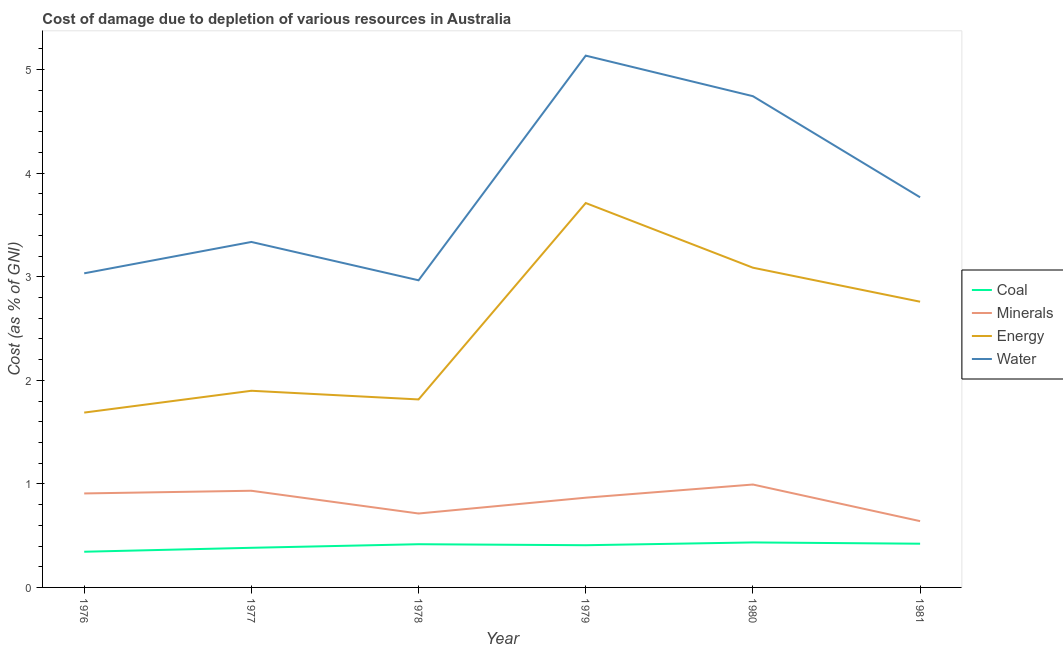Is the number of lines equal to the number of legend labels?
Make the answer very short. Yes. What is the cost of damage due to depletion of energy in 1981?
Offer a very short reply. 2.76. Across all years, what is the maximum cost of damage due to depletion of energy?
Your answer should be compact. 3.71. Across all years, what is the minimum cost of damage due to depletion of water?
Your answer should be compact. 2.97. In which year was the cost of damage due to depletion of minerals maximum?
Ensure brevity in your answer.  1980. In which year was the cost of damage due to depletion of water minimum?
Give a very brief answer. 1978. What is the total cost of damage due to depletion of coal in the graph?
Offer a terse response. 2.41. What is the difference between the cost of damage due to depletion of energy in 1977 and that in 1979?
Offer a very short reply. -1.81. What is the difference between the cost of damage due to depletion of minerals in 1978 and the cost of damage due to depletion of energy in 1979?
Offer a very short reply. -3. What is the average cost of damage due to depletion of minerals per year?
Give a very brief answer. 0.84. In the year 1981, what is the difference between the cost of damage due to depletion of minerals and cost of damage due to depletion of energy?
Offer a very short reply. -2.12. In how many years, is the cost of damage due to depletion of water greater than 4.4 %?
Offer a very short reply. 2. What is the ratio of the cost of damage due to depletion of minerals in 1977 to that in 1980?
Ensure brevity in your answer.  0.94. Is the difference between the cost of damage due to depletion of minerals in 1980 and 1981 greater than the difference between the cost of damage due to depletion of water in 1980 and 1981?
Your answer should be very brief. No. What is the difference between the highest and the second highest cost of damage due to depletion of water?
Offer a terse response. 0.39. What is the difference between the highest and the lowest cost of damage due to depletion of energy?
Offer a terse response. 2.02. Does the cost of damage due to depletion of coal monotonically increase over the years?
Your response must be concise. No. Is the cost of damage due to depletion of water strictly greater than the cost of damage due to depletion of minerals over the years?
Offer a very short reply. Yes. Is the cost of damage due to depletion of minerals strictly less than the cost of damage due to depletion of energy over the years?
Your answer should be very brief. Yes. How many lines are there?
Keep it short and to the point. 4. How many years are there in the graph?
Keep it short and to the point. 6. What is the difference between two consecutive major ticks on the Y-axis?
Keep it short and to the point. 1. Are the values on the major ticks of Y-axis written in scientific E-notation?
Offer a terse response. No. Does the graph contain grids?
Your answer should be very brief. No. How many legend labels are there?
Offer a terse response. 4. What is the title of the graph?
Keep it short and to the point. Cost of damage due to depletion of various resources in Australia . What is the label or title of the Y-axis?
Offer a very short reply. Cost (as % of GNI). What is the Cost (as % of GNI) of Coal in 1976?
Offer a very short reply. 0.34. What is the Cost (as % of GNI) in Minerals in 1976?
Make the answer very short. 0.91. What is the Cost (as % of GNI) in Energy in 1976?
Offer a terse response. 1.69. What is the Cost (as % of GNI) in Water in 1976?
Your answer should be very brief. 3.03. What is the Cost (as % of GNI) in Coal in 1977?
Your answer should be very brief. 0.38. What is the Cost (as % of GNI) in Minerals in 1977?
Provide a succinct answer. 0.93. What is the Cost (as % of GNI) of Energy in 1977?
Your answer should be very brief. 1.9. What is the Cost (as % of GNI) in Water in 1977?
Offer a very short reply. 3.34. What is the Cost (as % of GNI) in Coal in 1978?
Keep it short and to the point. 0.42. What is the Cost (as % of GNI) of Minerals in 1978?
Offer a very short reply. 0.71. What is the Cost (as % of GNI) in Energy in 1978?
Keep it short and to the point. 1.82. What is the Cost (as % of GNI) in Water in 1978?
Your response must be concise. 2.97. What is the Cost (as % of GNI) of Coal in 1979?
Your answer should be compact. 0.41. What is the Cost (as % of GNI) in Minerals in 1979?
Offer a terse response. 0.87. What is the Cost (as % of GNI) in Energy in 1979?
Your answer should be very brief. 3.71. What is the Cost (as % of GNI) of Water in 1979?
Your answer should be compact. 5.14. What is the Cost (as % of GNI) in Coal in 1980?
Provide a short and direct response. 0.43. What is the Cost (as % of GNI) in Minerals in 1980?
Provide a short and direct response. 0.99. What is the Cost (as % of GNI) in Energy in 1980?
Your answer should be very brief. 3.09. What is the Cost (as % of GNI) of Water in 1980?
Give a very brief answer. 4.74. What is the Cost (as % of GNI) in Coal in 1981?
Ensure brevity in your answer.  0.42. What is the Cost (as % of GNI) in Minerals in 1981?
Give a very brief answer. 0.64. What is the Cost (as % of GNI) in Energy in 1981?
Your response must be concise. 2.76. What is the Cost (as % of GNI) of Water in 1981?
Provide a short and direct response. 3.77. Across all years, what is the maximum Cost (as % of GNI) in Coal?
Ensure brevity in your answer.  0.43. Across all years, what is the maximum Cost (as % of GNI) in Minerals?
Your answer should be compact. 0.99. Across all years, what is the maximum Cost (as % of GNI) of Energy?
Provide a succinct answer. 3.71. Across all years, what is the maximum Cost (as % of GNI) of Water?
Provide a succinct answer. 5.14. Across all years, what is the minimum Cost (as % of GNI) in Coal?
Your response must be concise. 0.34. Across all years, what is the minimum Cost (as % of GNI) in Minerals?
Provide a succinct answer. 0.64. Across all years, what is the minimum Cost (as % of GNI) of Energy?
Offer a very short reply. 1.69. Across all years, what is the minimum Cost (as % of GNI) in Water?
Offer a very short reply. 2.97. What is the total Cost (as % of GNI) in Coal in the graph?
Provide a succinct answer. 2.41. What is the total Cost (as % of GNI) in Minerals in the graph?
Your response must be concise. 5.06. What is the total Cost (as % of GNI) of Energy in the graph?
Provide a succinct answer. 14.96. What is the total Cost (as % of GNI) in Water in the graph?
Offer a terse response. 22.98. What is the difference between the Cost (as % of GNI) in Coal in 1976 and that in 1977?
Ensure brevity in your answer.  -0.04. What is the difference between the Cost (as % of GNI) in Minerals in 1976 and that in 1977?
Offer a terse response. -0.03. What is the difference between the Cost (as % of GNI) in Energy in 1976 and that in 1977?
Provide a succinct answer. -0.21. What is the difference between the Cost (as % of GNI) of Water in 1976 and that in 1977?
Make the answer very short. -0.3. What is the difference between the Cost (as % of GNI) of Coal in 1976 and that in 1978?
Your answer should be compact. -0.07. What is the difference between the Cost (as % of GNI) of Minerals in 1976 and that in 1978?
Make the answer very short. 0.19. What is the difference between the Cost (as % of GNI) of Energy in 1976 and that in 1978?
Give a very brief answer. -0.13. What is the difference between the Cost (as % of GNI) of Water in 1976 and that in 1978?
Give a very brief answer. 0.07. What is the difference between the Cost (as % of GNI) of Coal in 1976 and that in 1979?
Ensure brevity in your answer.  -0.06. What is the difference between the Cost (as % of GNI) of Minerals in 1976 and that in 1979?
Give a very brief answer. 0.04. What is the difference between the Cost (as % of GNI) in Energy in 1976 and that in 1979?
Provide a short and direct response. -2.02. What is the difference between the Cost (as % of GNI) in Water in 1976 and that in 1979?
Offer a terse response. -2.1. What is the difference between the Cost (as % of GNI) of Coal in 1976 and that in 1980?
Provide a short and direct response. -0.09. What is the difference between the Cost (as % of GNI) in Minerals in 1976 and that in 1980?
Your response must be concise. -0.09. What is the difference between the Cost (as % of GNI) in Energy in 1976 and that in 1980?
Offer a very short reply. -1.4. What is the difference between the Cost (as % of GNI) in Water in 1976 and that in 1980?
Provide a succinct answer. -1.71. What is the difference between the Cost (as % of GNI) in Coal in 1976 and that in 1981?
Provide a succinct answer. -0.08. What is the difference between the Cost (as % of GNI) in Minerals in 1976 and that in 1981?
Make the answer very short. 0.27. What is the difference between the Cost (as % of GNI) of Energy in 1976 and that in 1981?
Offer a very short reply. -1.07. What is the difference between the Cost (as % of GNI) in Water in 1976 and that in 1981?
Offer a very short reply. -0.73. What is the difference between the Cost (as % of GNI) in Coal in 1977 and that in 1978?
Ensure brevity in your answer.  -0.03. What is the difference between the Cost (as % of GNI) in Minerals in 1977 and that in 1978?
Keep it short and to the point. 0.22. What is the difference between the Cost (as % of GNI) of Energy in 1977 and that in 1978?
Make the answer very short. 0.08. What is the difference between the Cost (as % of GNI) of Water in 1977 and that in 1978?
Give a very brief answer. 0.37. What is the difference between the Cost (as % of GNI) in Coal in 1977 and that in 1979?
Your answer should be compact. -0.02. What is the difference between the Cost (as % of GNI) of Minerals in 1977 and that in 1979?
Your answer should be compact. 0.07. What is the difference between the Cost (as % of GNI) of Energy in 1977 and that in 1979?
Provide a short and direct response. -1.81. What is the difference between the Cost (as % of GNI) of Water in 1977 and that in 1979?
Offer a very short reply. -1.8. What is the difference between the Cost (as % of GNI) in Coal in 1977 and that in 1980?
Your answer should be very brief. -0.05. What is the difference between the Cost (as % of GNI) in Minerals in 1977 and that in 1980?
Make the answer very short. -0.06. What is the difference between the Cost (as % of GNI) in Energy in 1977 and that in 1980?
Offer a terse response. -1.19. What is the difference between the Cost (as % of GNI) of Water in 1977 and that in 1980?
Your answer should be compact. -1.41. What is the difference between the Cost (as % of GNI) in Coal in 1977 and that in 1981?
Make the answer very short. -0.04. What is the difference between the Cost (as % of GNI) of Minerals in 1977 and that in 1981?
Provide a succinct answer. 0.29. What is the difference between the Cost (as % of GNI) of Energy in 1977 and that in 1981?
Offer a terse response. -0.86. What is the difference between the Cost (as % of GNI) of Water in 1977 and that in 1981?
Provide a succinct answer. -0.43. What is the difference between the Cost (as % of GNI) in Coal in 1978 and that in 1979?
Offer a terse response. 0.01. What is the difference between the Cost (as % of GNI) in Minerals in 1978 and that in 1979?
Offer a very short reply. -0.15. What is the difference between the Cost (as % of GNI) of Energy in 1978 and that in 1979?
Offer a very short reply. -1.9. What is the difference between the Cost (as % of GNI) in Water in 1978 and that in 1979?
Ensure brevity in your answer.  -2.17. What is the difference between the Cost (as % of GNI) in Coal in 1978 and that in 1980?
Ensure brevity in your answer.  -0.02. What is the difference between the Cost (as % of GNI) of Minerals in 1978 and that in 1980?
Make the answer very short. -0.28. What is the difference between the Cost (as % of GNI) of Energy in 1978 and that in 1980?
Make the answer very short. -1.27. What is the difference between the Cost (as % of GNI) of Water in 1978 and that in 1980?
Keep it short and to the point. -1.78. What is the difference between the Cost (as % of GNI) in Coal in 1978 and that in 1981?
Provide a short and direct response. -0. What is the difference between the Cost (as % of GNI) of Minerals in 1978 and that in 1981?
Provide a succinct answer. 0.07. What is the difference between the Cost (as % of GNI) in Energy in 1978 and that in 1981?
Provide a succinct answer. -0.94. What is the difference between the Cost (as % of GNI) in Water in 1978 and that in 1981?
Your response must be concise. -0.8. What is the difference between the Cost (as % of GNI) in Coal in 1979 and that in 1980?
Your answer should be very brief. -0.03. What is the difference between the Cost (as % of GNI) of Minerals in 1979 and that in 1980?
Give a very brief answer. -0.13. What is the difference between the Cost (as % of GNI) of Energy in 1979 and that in 1980?
Your answer should be very brief. 0.62. What is the difference between the Cost (as % of GNI) of Water in 1979 and that in 1980?
Provide a short and direct response. 0.39. What is the difference between the Cost (as % of GNI) in Coal in 1979 and that in 1981?
Make the answer very short. -0.01. What is the difference between the Cost (as % of GNI) of Minerals in 1979 and that in 1981?
Provide a succinct answer. 0.23. What is the difference between the Cost (as % of GNI) in Energy in 1979 and that in 1981?
Give a very brief answer. 0.95. What is the difference between the Cost (as % of GNI) of Water in 1979 and that in 1981?
Offer a terse response. 1.37. What is the difference between the Cost (as % of GNI) in Coal in 1980 and that in 1981?
Your answer should be very brief. 0.01. What is the difference between the Cost (as % of GNI) of Minerals in 1980 and that in 1981?
Your answer should be very brief. 0.35. What is the difference between the Cost (as % of GNI) in Energy in 1980 and that in 1981?
Provide a short and direct response. 0.33. What is the difference between the Cost (as % of GNI) in Water in 1980 and that in 1981?
Your answer should be very brief. 0.98. What is the difference between the Cost (as % of GNI) in Coal in 1976 and the Cost (as % of GNI) in Minerals in 1977?
Make the answer very short. -0.59. What is the difference between the Cost (as % of GNI) of Coal in 1976 and the Cost (as % of GNI) of Energy in 1977?
Keep it short and to the point. -1.55. What is the difference between the Cost (as % of GNI) of Coal in 1976 and the Cost (as % of GNI) of Water in 1977?
Your response must be concise. -2.99. What is the difference between the Cost (as % of GNI) of Minerals in 1976 and the Cost (as % of GNI) of Energy in 1977?
Offer a very short reply. -0.99. What is the difference between the Cost (as % of GNI) in Minerals in 1976 and the Cost (as % of GNI) in Water in 1977?
Keep it short and to the point. -2.43. What is the difference between the Cost (as % of GNI) of Energy in 1976 and the Cost (as % of GNI) of Water in 1977?
Ensure brevity in your answer.  -1.65. What is the difference between the Cost (as % of GNI) in Coal in 1976 and the Cost (as % of GNI) in Minerals in 1978?
Give a very brief answer. -0.37. What is the difference between the Cost (as % of GNI) of Coal in 1976 and the Cost (as % of GNI) of Energy in 1978?
Provide a short and direct response. -1.47. What is the difference between the Cost (as % of GNI) in Coal in 1976 and the Cost (as % of GNI) in Water in 1978?
Your answer should be very brief. -2.62. What is the difference between the Cost (as % of GNI) in Minerals in 1976 and the Cost (as % of GNI) in Energy in 1978?
Make the answer very short. -0.91. What is the difference between the Cost (as % of GNI) of Minerals in 1976 and the Cost (as % of GNI) of Water in 1978?
Ensure brevity in your answer.  -2.06. What is the difference between the Cost (as % of GNI) in Energy in 1976 and the Cost (as % of GNI) in Water in 1978?
Offer a terse response. -1.28. What is the difference between the Cost (as % of GNI) in Coal in 1976 and the Cost (as % of GNI) in Minerals in 1979?
Offer a terse response. -0.52. What is the difference between the Cost (as % of GNI) of Coal in 1976 and the Cost (as % of GNI) of Energy in 1979?
Ensure brevity in your answer.  -3.37. What is the difference between the Cost (as % of GNI) in Coal in 1976 and the Cost (as % of GNI) in Water in 1979?
Give a very brief answer. -4.79. What is the difference between the Cost (as % of GNI) of Minerals in 1976 and the Cost (as % of GNI) of Energy in 1979?
Provide a succinct answer. -2.8. What is the difference between the Cost (as % of GNI) of Minerals in 1976 and the Cost (as % of GNI) of Water in 1979?
Ensure brevity in your answer.  -4.23. What is the difference between the Cost (as % of GNI) of Energy in 1976 and the Cost (as % of GNI) of Water in 1979?
Offer a terse response. -3.45. What is the difference between the Cost (as % of GNI) of Coal in 1976 and the Cost (as % of GNI) of Minerals in 1980?
Offer a terse response. -0.65. What is the difference between the Cost (as % of GNI) in Coal in 1976 and the Cost (as % of GNI) in Energy in 1980?
Give a very brief answer. -2.74. What is the difference between the Cost (as % of GNI) of Coal in 1976 and the Cost (as % of GNI) of Water in 1980?
Your response must be concise. -4.4. What is the difference between the Cost (as % of GNI) in Minerals in 1976 and the Cost (as % of GNI) in Energy in 1980?
Keep it short and to the point. -2.18. What is the difference between the Cost (as % of GNI) of Minerals in 1976 and the Cost (as % of GNI) of Water in 1980?
Offer a very short reply. -3.84. What is the difference between the Cost (as % of GNI) in Energy in 1976 and the Cost (as % of GNI) in Water in 1980?
Your response must be concise. -3.06. What is the difference between the Cost (as % of GNI) in Coal in 1976 and the Cost (as % of GNI) in Minerals in 1981?
Your answer should be very brief. -0.3. What is the difference between the Cost (as % of GNI) in Coal in 1976 and the Cost (as % of GNI) in Energy in 1981?
Offer a terse response. -2.41. What is the difference between the Cost (as % of GNI) in Coal in 1976 and the Cost (as % of GNI) in Water in 1981?
Provide a short and direct response. -3.42. What is the difference between the Cost (as % of GNI) of Minerals in 1976 and the Cost (as % of GNI) of Energy in 1981?
Offer a very short reply. -1.85. What is the difference between the Cost (as % of GNI) of Minerals in 1976 and the Cost (as % of GNI) of Water in 1981?
Your response must be concise. -2.86. What is the difference between the Cost (as % of GNI) of Energy in 1976 and the Cost (as % of GNI) of Water in 1981?
Offer a terse response. -2.08. What is the difference between the Cost (as % of GNI) in Coal in 1977 and the Cost (as % of GNI) in Minerals in 1978?
Give a very brief answer. -0.33. What is the difference between the Cost (as % of GNI) of Coal in 1977 and the Cost (as % of GNI) of Energy in 1978?
Provide a short and direct response. -1.43. What is the difference between the Cost (as % of GNI) in Coal in 1977 and the Cost (as % of GNI) in Water in 1978?
Make the answer very short. -2.58. What is the difference between the Cost (as % of GNI) of Minerals in 1977 and the Cost (as % of GNI) of Energy in 1978?
Provide a short and direct response. -0.88. What is the difference between the Cost (as % of GNI) in Minerals in 1977 and the Cost (as % of GNI) in Water in 1978?
Make the answer very short. -2.03. What is the difference between the Cost (as % of GNI) in Energy in 1977 and the Cost (as % of GNI) in Water in 1978?
Make the answer very short. -1.07. What is the difference between the Cost (as % of GNI) of Coal in 1977 and the Cost (as % of GNI) of Minerals in 1979?
Ensure brevity in your answer.  -0.48. What is the difference between the Cost (as % of GNI) of Coal in 1977 and the Cost (as % of GNI) of Energy in 1979?
Your answer should be very brief. -3.33. What is the difference between the Cost (as % of GNI) of Coal in 1977 and the Cost (as % of GNI) of Water in 1979?
Provide a succinct answer. -4.75. What is the difference between the Cost (as % of GNI) of Minerals in 1977 and the Cost (as % of GNI) of Energy in 1979?
Make the answer very short. -2.78. What is the difference between the Cost (as % of GNI) of Minerals in 1977 and the Cost (as % of GNI) of Water in 1979?
Ensure brevity in your answer.  -4.2. What is the difference between the Cost (as % of GNI) in Energy in 1977 and the Cost (as % of GNI) in Water in 1979?
Give a very brief answer. -3.24. What is the difference between the Cost (as % of GNI) of Coal in 1977 and the Cost (as % of GNI) of Minerals in 1980?
Provide a short and direct response. -0.61. What is the difference between the Cost (as % of GNI) in Coal in 1977 and the Cost (as % of GNI) in Energy in 1980?
Your answer should be compact. -2.7. What is the difference between the Cost (as % of GNI) of Coal in 1977 and the Cost (as % of GNI) of Water in 1980?
Offer a terse response. -4.36. What is the difference between the Cost (as % of GNI) in Minerals in 1977 and the Cost (as % of GNI) in Energy in 1980?
Ensure brevity in your answer.  -2.15. What is the difference between the Cost (as % of GNI) in Minerals in 1977 and the Cost (as % of GNI) in Water in 1980?
Your answer should be compact. -3.81. What is the difference between the Cost (as % of GNI) in Energy in 1977 and the Cost (as % of GNI) in Water in 1980?
Offer a very short reply. -2.84. What is the difference between the Cost (as % of GNI) in Coal in 1977 and the Cost (as % of GNI) in Minerals in 1981?
Give a very brief answer. -0.26. What is the difference between the Cost (as % of GNI) in Coal in 1977 and the Cost (as % of GNI) in Energy in 1981?
Offer a very short reply. -2.38. What is the difference between the Cost (as % of GNI) of Coal in 1977 and the Cost (as % of GNI) of Water in 1981?
Keep it short and to the point. -3.38. What is the difference between the Cost (as % of GNI) in Minerals in 1977 and the Cost (as % of GNI) in Energy in 1981?
Your response must be concise. -1.83. What is the difference between the Cost (as % of GNI) of Minerals in 1977 and the Cost (as % of GNI) of Water in 1981?
Your response must be concise. -2.83. What is the difference between the Cost (as % of GNI) in Energy in 1977 and the Cost (as % of GNI) in Water in 1981?
Your answer should be very brief. -1.87. What is the difference between the Cost (as % of GNI) in Coal in 1978 and the Cost (as % of GNI) in Minerals in 1979?
Ensure brevity in your answer.  -0.45. What is the difference between the Cost (as % of GNI) of Coal in 1978 and the Cost (as % of GNI) of Energy in 1979?
Provide a short and direct response. -3.29. What is the difference between the Cost (as % of GNI) of Coal in 1978 and the Cost (as % of GNI) of Water in 1979?
Provide a short and direct response. -4.72. What is the difference between the Cost (as % of GNI) of Minerals in 1978 and the Cost (as % of GNI) of Energy in 1979?
Your response must be concise. -3. What is the difference between the Cost (as % of GNI) in Minerals in 1978 and the Cost (as % of GNI) in Water in 1979?
Your answer should be compact. -4.42. What is the difference between the Cost (as % of GNI) of Energy in 1978 and the Cost (as % of GNI) of Water in 1979?
Make the answer very short. -3.32. What is the difference between the Cost (as % of GNI) of Coal in 1978 and the Cost (as % of GNI) of Minerals in 1980?
Give a very brief answer. -0.58. What is the difference between the Cost (as % of GNI) in Coal in 1978 and the Cost (as % of GNI) in Energy in 1980?
Your answer should be very brief. -2.67. What is the difference between the Cost (as % of GNI) of Coal in 1978 and the Cost (as % of GNI) of Water in 1980?
Your answer should be compact. -4.33. What is the difference between the Cost (as % of GNI) of Minerals in 1978 and the Cost (as % of GNI) of Energy in 1980?
Make the answer very short. -2.37. What is the difference between the Cost (as % of GNI) of Minerals in 1978 and the Cost (as % of GNI) of Water in 1980?
Your answer should be compact. -4.03. What is the difference between the Cost (as % of GNI) in Energy in 1978 and the Cost (as % of GNI) in Water in 1980?
Keep it short and to the point. -2.93. What is the difference between the Cost (as % of GNI) in Coal in 1978 and the Cost (as % of GNI) in Minerals in 1981?
Keep it short and to the point. -0.22. What is the difference between the Cost (as % of GNI) in Coal in 1978 and the Cost (as % of GNI) in Energy in 1981?
Keep it short and to the point. -2.34. What is the difference between the Cost (as % of GNI) in Coal in 1978 and the Cost (as % of GNI) in Water in 1981?
Keep it short and to the point. -3.35. What is the difference between the Cost (as % of GNI) in Minerals in 1978 and the Cost (as % of GNI) in Energy in 1981?
Ensure brevity in your answer.  -2.05. What is the difference between the Cost (as % of GNI) in Minerals in 1978 and the Cost (as % of GNI) in Water in 1981?
Your answer should be very brief. -3.05. What is the difference between the Cost (as % of GNI) in Energy in 1978 and the Cost (as % of GNI) in Water in 1981?
Offer a very short reply. -1.95. What is the difference between the Cost (as % of GNI) of Coal in 1979 and the Cost (as % of GNI) of Minerals in 1980?
Provide a succinct answer. -0.59. What is the difference between the Cost (as % of GNI) in Coal in 1979 and the Cost (as % of GNI) in Energy in 1980?
Ensure brevity in your answer.  -2.68. What is the difference between the Cost (as % of GNI) in Coal in 1979 and the Cost (as % of GNI) in Water in 1980?
Keep it short and to the point. -4.34. What is the difference between the Cost (as % of GNI) of Minerals in 1979 and the Cost (as % of GNI) of Energy in 1980?
Offer a very short reply. -2.22. What is the difference between the Cost (as % of GNI) in Minerals in 1979 and the Cost (as % of GNI) in Water in 1980?
Give a very brief answer. -3.88. What is the difference between the Cost (as % of GNI) in Energy in 1979 and the Cost (as % of GNI) in Water in 1980?
Give a very brief answer. -1.03. What is the difference between the Cost (as % of GNI) in Coal in 1979 and the Cost (as % of GNI) in Minerals in 1981?
Make the answer very short. -0.23. What is the difference between the Cost (as % of GNI) in Coal in 1979 and the Cost (as % of GNI) in Energy in 1981?
Ensure brevity in your answer.  -2.35. What is the difference between the Cost (as % of GNI) in Coal in 1979 and the Cost (as % of GNI) in Water in 1981?
Your answer should be very brief. -3.36. What is the difference between the Cost (as % of GNI) of Minerals in 1979 and the Cost (as % of GNI) of Energy in 1981?
Your response must be concise. -1.89. What is the difference between the Cost (as % of GNI) of Minerals in 1979 and the Cost (as % of GNI) of Water in 1981?
Ensure brevity in your answer.  -2.9. What is the difference between the Cost (as % of GNI) in Energy in 1979 and the Cost (as % of GNI) in Water in 1981?
Provide a succinct answer. -0.06. What is the difference between the Cost (as % of GNI) in Coal in 1980 and the Cost (as % of GNI) in Minerals in 1981?
Your response must be concise. -0.21. What is the difference between the Cost (as % of GNI) in Coal in 1980 and the Cost (as % of GNI) in Energy in 1981?
Your response must be concise. -2.32. What is the difference between the Cost (as % of GNI) of Coal in 1980 and the Cost (as % of GNI) of Water in 1981?
Provide a succinct answer. -3.33. What is the difference between the Cost (as % of GNI) of Minerals in 1980 and the Cost (as % of GNI) of Energy in 1981?
Ensure brevity in your answer.  -1.77. What is the difference between the Cost (as % of GNI) of Minerals in 1980 and the Cost (as % of GNI) of Water in 1981?
Give a very brief answer. -2.77. What is the difference between the Cost (as % of GNI) in Energy in 1980 and the Cost (as % of GNI) in Water in 1981?
Your answer should be compact. -0.68. What is the average Cost (as % of GNI) in Coal per year?
Your answer should be very brief. 0.4. What is the average Cost (as % of GNI) in Minerals per year?
Ensure brevity in your answer.  0.84. What is the average Cost (as % of GNI) in Energy per year?
Give a very brief answer. 2.49. What is the average Cost (as % of GNI) in Water per year?
Your answer should be compact. 3.83. In the year 1976, what is the difference between the Cost (as % of GNI) in Coal and Cost (as % of GNI) in Minerals?
Provide a short and direct response. -0.56. In the year 1976, what is the difference between the Cost (as % of GNI) in Coal and Cost (as % of GNI) in Energy?
Your answer should be compact. -1.34. In the year 1976, what is the difference between the Cost (as % of GNI) of Coal and Cost (as % of GNI) of Water?
Your answer should be very brief. -2.69. In the year 1976, what is the difference between the Cost (as % of GNI) in Minerals and Cost (as % of GNI) in Energy?
Offer a very short reply. -0.78. In the year 1976, what is the difference between the Cost (as % of GNI) of Minerals and Cost (as % of GNI) of Water?
Keep it short and to the point. -2.13. In the year 1976, what is the difference between the Cost (as % of GNI) of Energy and Cost (as % of GNI) of Water?
Give a very brief answer. -1.34. In the year 1977, what is the difference between the Cost (as % of GNI) of Coal and Cost (as % of GNI) of Minerals?
Make the answer very short. -0.55. In the year 1977, what is the difference between the Cost (as % of GNI) of Coal and Cost (as % of GNI) of Energy?
Give a very brief answer. -1.52. In the year 1977, what is the difference between the Cost (as % of GNI) in Coal and Cost (as % of GNI) in Water?
Give a very brief answer. -2.95. In the year 1977, what is the difference between the Cost (as % of GNI) in Minerals and Cost (as % of GNI) in Energy?
Make the answer very short. -0.97. In the year 1977, what is the difference between the Cost (as % of GNI) of Minerals and Cost (as % of GNI) of Water?
Provide a short and direct response. -2.4. In the year 1977, what is the difference between the Cost (as % of GNI) of Energy and Cost (as % of GNI) of Water?
Give a very brief answer. -1.44. In the year 1978, what is the difference between the Cost (as % of GNI) in Coal and Cost (as % of GNI) in Minerals?
Offer a terse response. -0.3. In the year 1978, what is the difference between the Cost (as % of GNI) in Coal and Cost (as % of GNI) in Energy?
Ensure brevity in your answer.  -1.4. In the year 1978, what is the difference between the Cost (as % of GNI) of Coal and Cost (as % of GNI) of Water?
Keep it short and to the point. -2.55. In the year 1978, what is the difference between the Cost (as % of GNI) in Minerals and Cost (as % of GNI) in Energy?
Your response must be concise. -1.1. In the year 1978, what is the difference between the Cost (as % of GNI) in Minerals and Cost (as % of GNI) in Water?
Make the answer very short. -2.25. In the year 1978, what is the difference between the Cost (as % of GNI) in Energy and Cost (as % of GNI) in Water?
Make the answer very short. -1.15. In the year 1979, what is the difference between the Cost (as % of GNI) of Coal and Cost (as % of GNI) of Minerals?
Your answer should be very brief. -0.46. In the year 1979, what is the difference between the Cost (as % of GNI) of Coal and Cost (as % of GNI) of Energy?
Provide a short and direct response. -3.3. In the year 1979, what is the difference between the Cost (as % of GNI) in Coal and Cost (as % of GNI) in Water?
Provide a short and direct response. -4.73. In the year 1979, what is the difference between the Cost (as % of GNI) in Minerals and Cost (as % of GNI) in Energy?
Give a very brief answer. -2.85. In the year 1979, what is the difference between the Cost (as % of GNI) of Minerals and Cost (as % of GNI) of Water?
Keep it short and to the point. -4.27. In the year 1979, what is the difference between the Cost (as % of GNI) in Energy and Cost (as % of GNI) in Water?
Make the answer very short. -1.42. In the year 1980, what is the difference between the Cost (as % of GNI) in Coal and Cost (as % of GNI) in Minerals?
Offer a terse response. -0.56. In the year 1980, what is the difference between the Cost (as % of GNI) in Coal and Cost (as % of GNI) in Energy?
Ensure brevity in your answer.  -2.65. In the year 1980, what is the difference between the Cost (as % of GNI) in Coal and Cost (as % of GNI) in Water?
Your response must be concise. -4.31. In the year 1980, what is the difference between the Cost (as % of GNI) of Minerals and Cost (as % of GNI) of Energy?
Ensure brevity in your answer.  -2.09. In the year 1980, what is the difference between the Cost (as % of GNI) in Minerals and Cost (as % of GNI) in Water?
Keep it short and to the point. -3.75. In the year 1980, what is the difference between the Cost (as % of GNI) of Energy and Cost (as % of GNI) of Water?
Offer a terse response. -1.66. In the year 1981, what is the difference between the Cost (as % of GNI) in Coal and Cost (as % of GNI) in Minerals?
Your response must be concise. -0.22. In the year 1981, what is the difference between the Cost (as % of GNI) of Coal and Cost (as % of GNI) of Energy?
Offer a very short reply. -2.34. In the year 1981, what is the difference between the Cost (as % of GNI) of Coal and Cost (as % of GNI) of Water?
Keep it short and to the point. -3.35. In the year 1981, what is the difference between the Cost (as % of GNI) of Minerals and Cost (as % of GNI) of Energy?
Give a very brief answer. -2.12. In the year 1981, what is the difference between the Cost (as % of GNI) of Minerals and Cost (as % of GNI) of Water?
Ensure brevity in your answer.  -3.13. In the year 1981, what is the difference between the Cost (as % of GNI) of Energy and Cost (as % of GNI) of Water?
Provide a succinct answer. -1.01. What is the ratio of the Cost (as % of GNI) of Coal in 1976 to that in 1977?
Provide a short and direct response. 0.9. What is the ratio of the Cost (as % of GNI) in Minerals in 1976 to that in 1977?
Your answer should be very brief. 0.97. What is the ratio of the Cost (as % of GNI) of Energy in 1976 to that in 1977?
Offer a very short reply. 0.89. What is the ratio of the Cost (as % of GNI) of Water in 1976 to that in 1977?
Make the answer very short. 0.91. What is the ratio of the Cost (as % of GNI) in Coal in 1976 to that in 1978?
Your response must be concise. 0.83. What is the ratio of the Cost (as % of GNI) of Minerals in 1976 to that in 1978?
Your answer should be compact. 1.27. What is the ratio of the Cost (as % of GNI) in Energy in 1976 to that in 1978?
Ensure brevity in your answer.  0.93. What is the ratio of the Cost (as % of GNI) of Water in 1976 to that in 1978?
Keep it short and to the point. 1.02. What is the ratio of the Cost (as % of GNI) of Coal in 1976 to that in 1979?
Ensure brevity in your answer.  0.85. What is the ratio of the Cost (as % of GNI) of Minerals in 1976 to that in 1979?
Your answer should be compact. 1.05. What is the ratio of the Cost (as % of GNI) of Energy in 1976 to that in 1979?
Ensure brevity in your answer.  0.45. What is the ratio of the Cost (as % of GNI) in Water in 1976 to that in 1979?
Provide a short and direct response. 0.59. What is the ratio of the Cost (as % of GNI) in Coal in 1976 to that in 1980?
Your response must be concise. 0.79. What is the ratio of the Cost (as % of GNI) of Minerals in 1976 to that in 1980?
Keep it short and to the point. 0.91. What is the ratio of the Cost (as % of GNI) of Energy in 1976 to that in 1980?
Make the answer very short. 0.55. What is the ratio of the Cost (as % of GNI) of Water in 1976 to that in 1980?
Your answer should be compact. 0.64. What is the ratio of the Cost (as % of GNI) of Coal in 1976 to that in 1981?
Provide a succinct answer. 0.82. What is the ratio of the Cost (as % of GNI) in Minerals in 1976 to that in 1981?
Provide a succinct answer. 1.42. What is the ratio of the Cost (as % of GNI) of Energy in 1976 to that in 1981?
Ensure brevity in your answer.  0.61. What is the ratio of the Cost (as % of GNI) in Water in 1976 to that in 1981?
Provide a short and direct response. 0.81. What is the ratio of the Cost (as % of GNI) in Coal in 1977 to that in 1978?
Your answer should be very brief. 0.92. What is the ratio of the Cost (as % of GNI) in Minerals in 1977 to that in 1978?
Make the answer very short. 1.31. What is the ratio of the Cost (as % of GNI) of Energy in 1977 to that in 1978?
Your answer should be compact. 1.05. What is the ratio of the Cost (as % of GNI) in Water in 1977 to that in 1978?
Provide a succinct answer. 1.12. What is the ratio of the Cost (as % of GNI) in Coal in 1977 to that in 1979?
Your answer should be very brief. 0.94. What is the ratio of the Cost (as % of GNI) in Minerals in 1977 to that in 1979?
Provide a short and direct response. 1.08. What is the ratio of the Cost (as % of GNI) of Energy in 1977 to that in 1979?
Your answer should be compact. 0.51. What is the ratio of the Cost (as % of GNI) in Water in 1977 to that in 1979?
Your answer should be very brief. 0.65. What is the ratio of the Cost (as % of GNI) in Coal in 1977 to that in 1980?
Your answer should be compact. 0.88. What is the ratio of the Cost (as % of GNI) in Minerals in 1977 to that in 1980?
Make the answer very short. 0.94. What is the ratio of the Cost (as % of GNI) of Energy in 1977 to that in 1980?
Provide a short and direct response. 0.62. What is the ratio of the Cost (as % of GNI) in Water in 1977 to that in 1980?
Make the answer very short. 0.7. What is the ratio of the Cost (as % of GNI) in Coal in 1977 to that in 1981?
Your answer should be compact. 0.91. What is the ratio of the Cost (as % of GNI) of Minerals in 1977 to that in 1981?
Offer a terse response. 1.46. What is the ratio of the Cost (as % of GNI) in Energy in 1977 to that in 1981?
Provide a short and direct response. 0.69. What is the ratio of the Cost (as % of GNI) in Water in 1977 to that in 1981?
Offer a very short reply. 0.89. What is the ratio of the Cost (as % of GNI) of Coal in 1978 to that in 1979?
Provide a short and direct response. 1.02. What is the ratio of the Cost (as % of GNI) in Minerals in 1978 to that in 1979?
Ensure brevity in your answer.  0.82. What is the ratio of the Cost (as % of GNI) in Energy in 1978 to that in 1979?
Your answer should be compact. 0.49. What is the ratio of the Cost (as % of GNI) of Water in 1978 to that in 1979?
Provide a short and direct response. 0.58. What is the ratio of the Cost (as % of GNI) of Coal in 1978 to that in 1980?
Offer a very short reply. 0.96. What is the ratio of the Cost (as % of GNI) of Minerals in 1978 to that in 1980?
Keep it short and to the point. 0.72. What is the ratio of the Cost (as % of GNI) in Energy in 1978 to that in 1980?
Provide a succinct answer. 0.59. What is the ratio of the Cost (as % of GNI) in Water in 1978 to that in 1980?
Ensure brevity in your answer.  0.63. What is the ratio of the Cost (as % of GNI) of Coal in 1978 to that in 1981?
Ensure brevity in your answer.  0.99. What is the ratio of the Cost (as % of GNI) in Minerals in 1978 to that in 1981?
Provide a succinct answer. 1.12. What is the ratio of the Cost (as % of GNI) of Energy in 1978 to that in 1981?
Your answer should be compact. 0.66. What is the ratio of the Cost (as % of GNI) of Water in 1978 to that in 1981?
Your answer should be compact. 0.79. What is the ratio of the Cost (as % of GNI) of Coal in 1979 to that in 1980?
Your response must be concise. 0.94. What is the ratio of the Cost (as % of GNI) of Minerals in 1979 to that in 1980?
Make the answer very short. 0.87. What is the ratio of the Cost (as % of GNI) in Energy in 1979 to that in 1980?
Provide a short and direct response. 1.2. What is the ratio of the Cost (as % of GNI) in Water in 1979 to that in 1980?
Your answer should be very brief. 1.08. What is the ratio of the Cost (as % of GNI) of Coal in 1979 to that in 1981?
Your response must be concise. 0.97. What is the ratio of the Cost (as % of GNI) in Minerals in 1979 to that in 1981?
Your response must be concise. 1.35. What is the ratio of the Cost (as % of GNI) in Energy in 1979 to that in 1981?
Offer a very short reply. 1.35. What is the ratio of the Cost (as % of GNI) in Water in 1979 to that in 1981?
Make the answer very short. 1.36. What is the ratio of the Cost (as % of GNI) in Coal in 1980 to that in 1981?
Your answer should be very brief. 1.03. What is the ratio of the Cost (as % of GNI) in Minerals in 1980 to that in 1981?
Make the answer very short. 1.55. What is the ratio of the Cost (as % of GNI) of Energy in 1980 to that in 1981?
Your answer should be very brief. 1.12. What is the ratio of the Cost (as % of GNI) in Water in 1980 to that in 1981?
Keep it short and to the point. 1.26. What is the difference between the highest and the second highest Cost (as % of GNI) of Coal?
Ensure brevity in your answer.  0.01. What is the difference between the highest and the second highest Cost (as % of GNI) in Minerals?
Offer a very short reply. 0.06. What is the difference between the highest and the second highest Cost (as % of GNI) in Energy?
Keep it short and to the point. 0.62. What is the difference between the highest and the second highest Cost (as % of GNI) of Water?
Provide a short and direct response. 0.39. What is the difference between the highest and the lowest Cost (as % of GNI) of Coal?
Make the answer very short. 0.09. What is the difference between the highest and the lowest Cost (as % of GNI) in Minerals?
Your response must be concise. 0.35. What is the difference between the highest and the lowest Cost (as % of GNI) of Energy?
Offer a terse response. 2.02. What is the difference between the highest and the lowest Cost (as % of GNI) in Water?
Offer a very short reply. 2.17. 